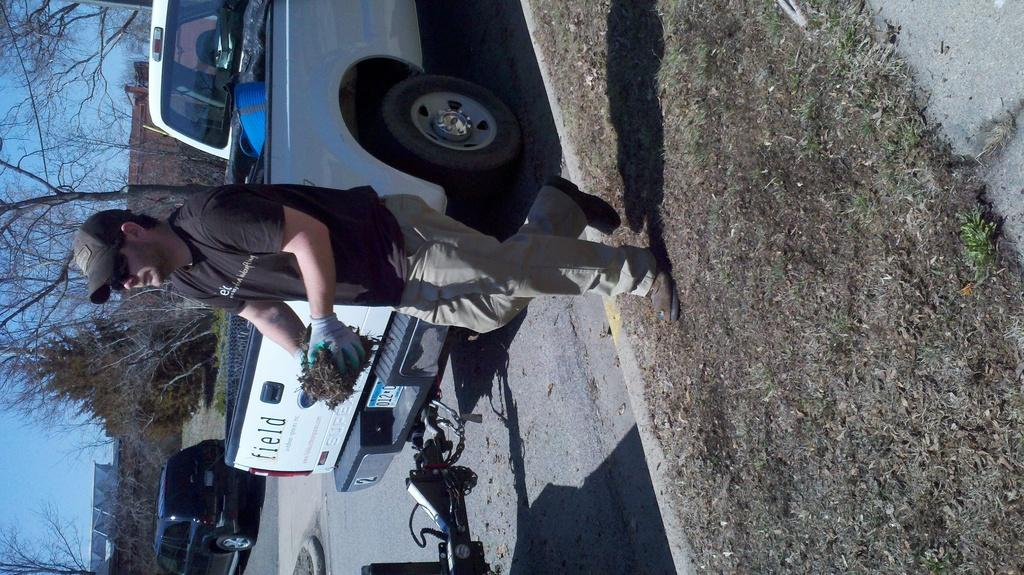What type of vehicles can be seen in the image? There are cars in the image. Can you describe the person in the image? There is a person standing in the image. What type of natural vegetation is visible in the image? There are trees visible in the image. What part of the natural environment is visible in the image? The sky is visible in the image. What type of cable is being used by the person in the image? There is no cable visible in the image; the person is simply standing. How many cats are present in the image? There are no cats present in the image. 